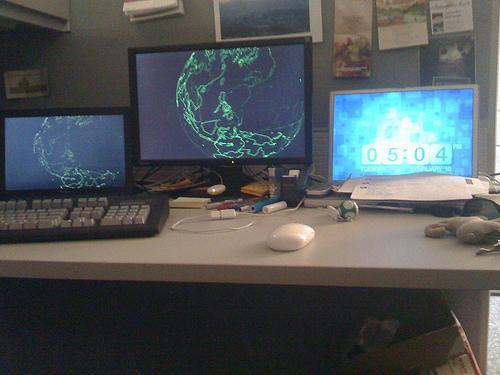How many screens are there?
Give a very brief answer. 3. How many mice are there?
Give a very brief answer. 1. 